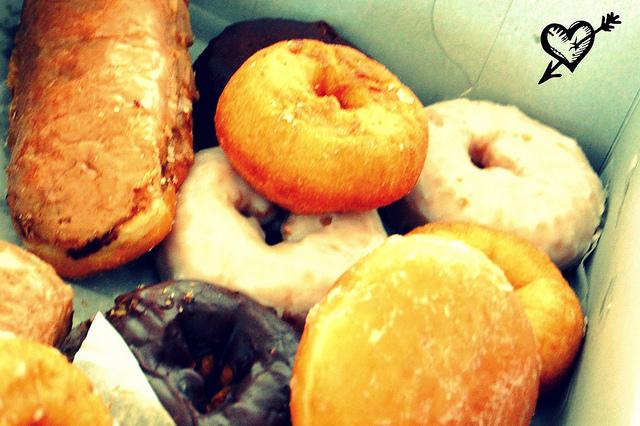What is drawn on the box?
Write a very short answer. Heart. What desserts are these?
Give a very brief answer. Donuts. How many donuts have vanilla frosting?
Quick response, please. 2. 